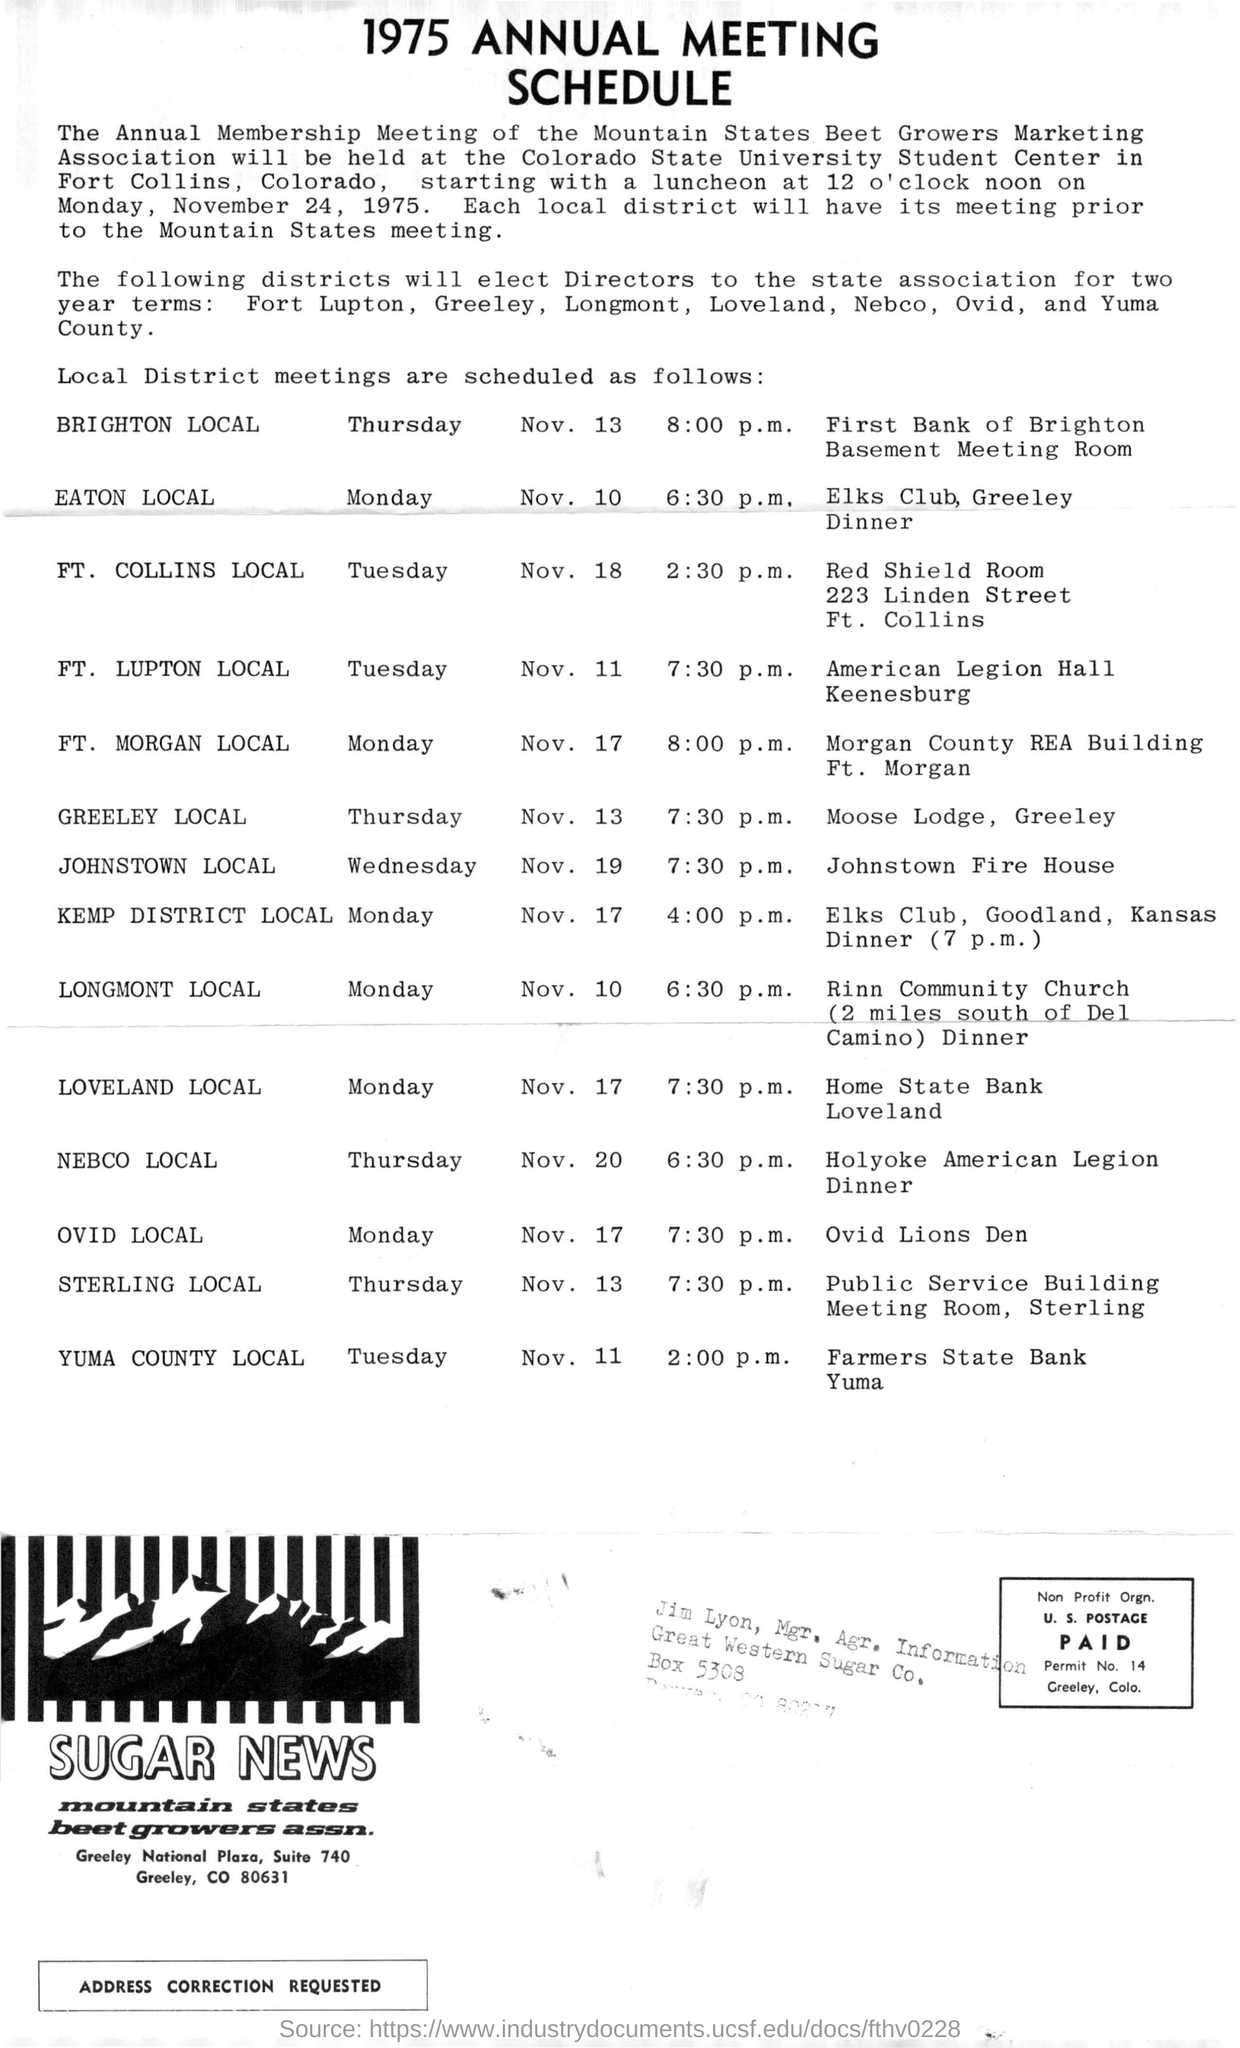Specify some key components in this picture. The Annual Membership Meeting of the Mountain States Beet Growers Marketing Association is held at the Colorado State University Student Center. The given schedule is a 1975 annual meeting schedule. The Colorado State University Student Center is located in Fort Collins, Colorado. 